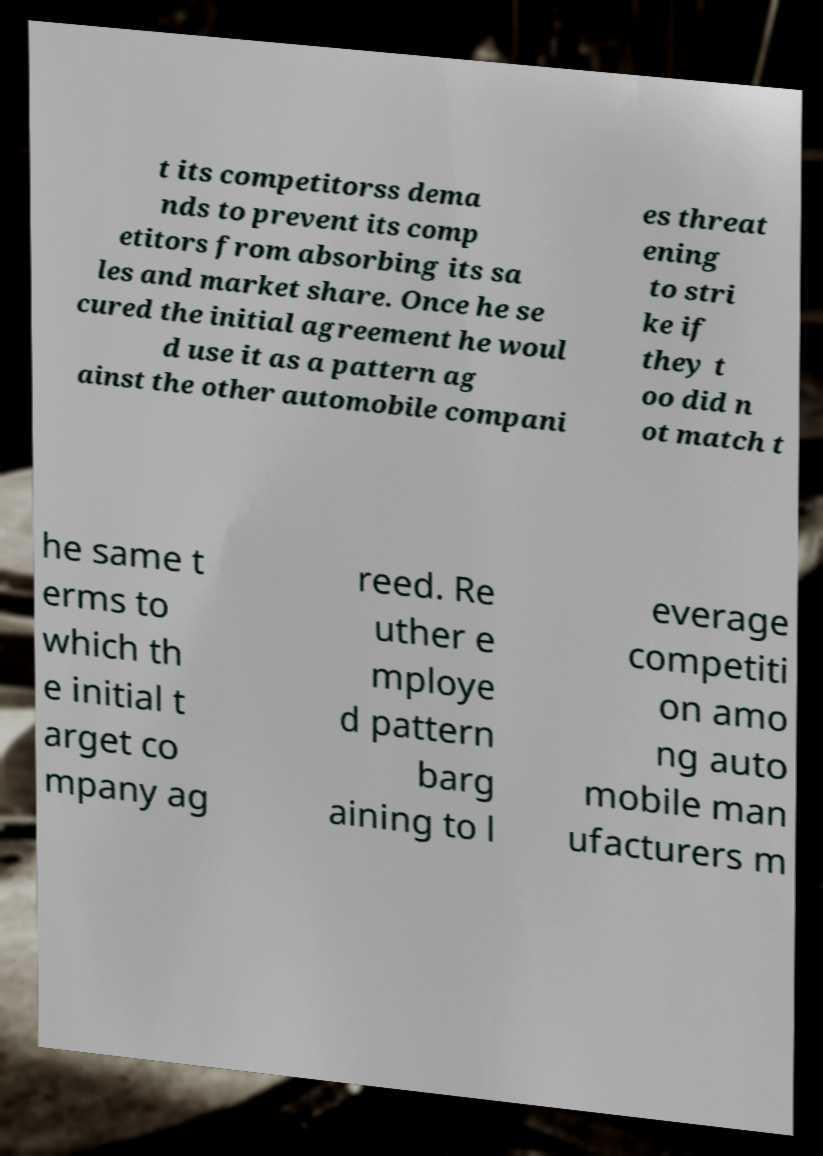Could you assist in decoding the text presented in this image and type it out clearly? t its competitorss dema nds to prevent its comp etitors from absorbing its sa les and market share. Once he se cured the initial agreement he woul d use it as a pattern ag ainst the other automobile compani es threat ening to stri ke if they t oo did n ot match t he same t erms to which th e initial t arget co mpany ag reed. Re uther e mploye d pattern barg aining to l everage competiti on amo ng auto mobile man ufacturers m 